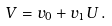Convert formula to latex. <formula><loc_0><loc_0><loc_500><loc_500>V = v _ { 0 } + v _ { 1 } U \, .</formula> 